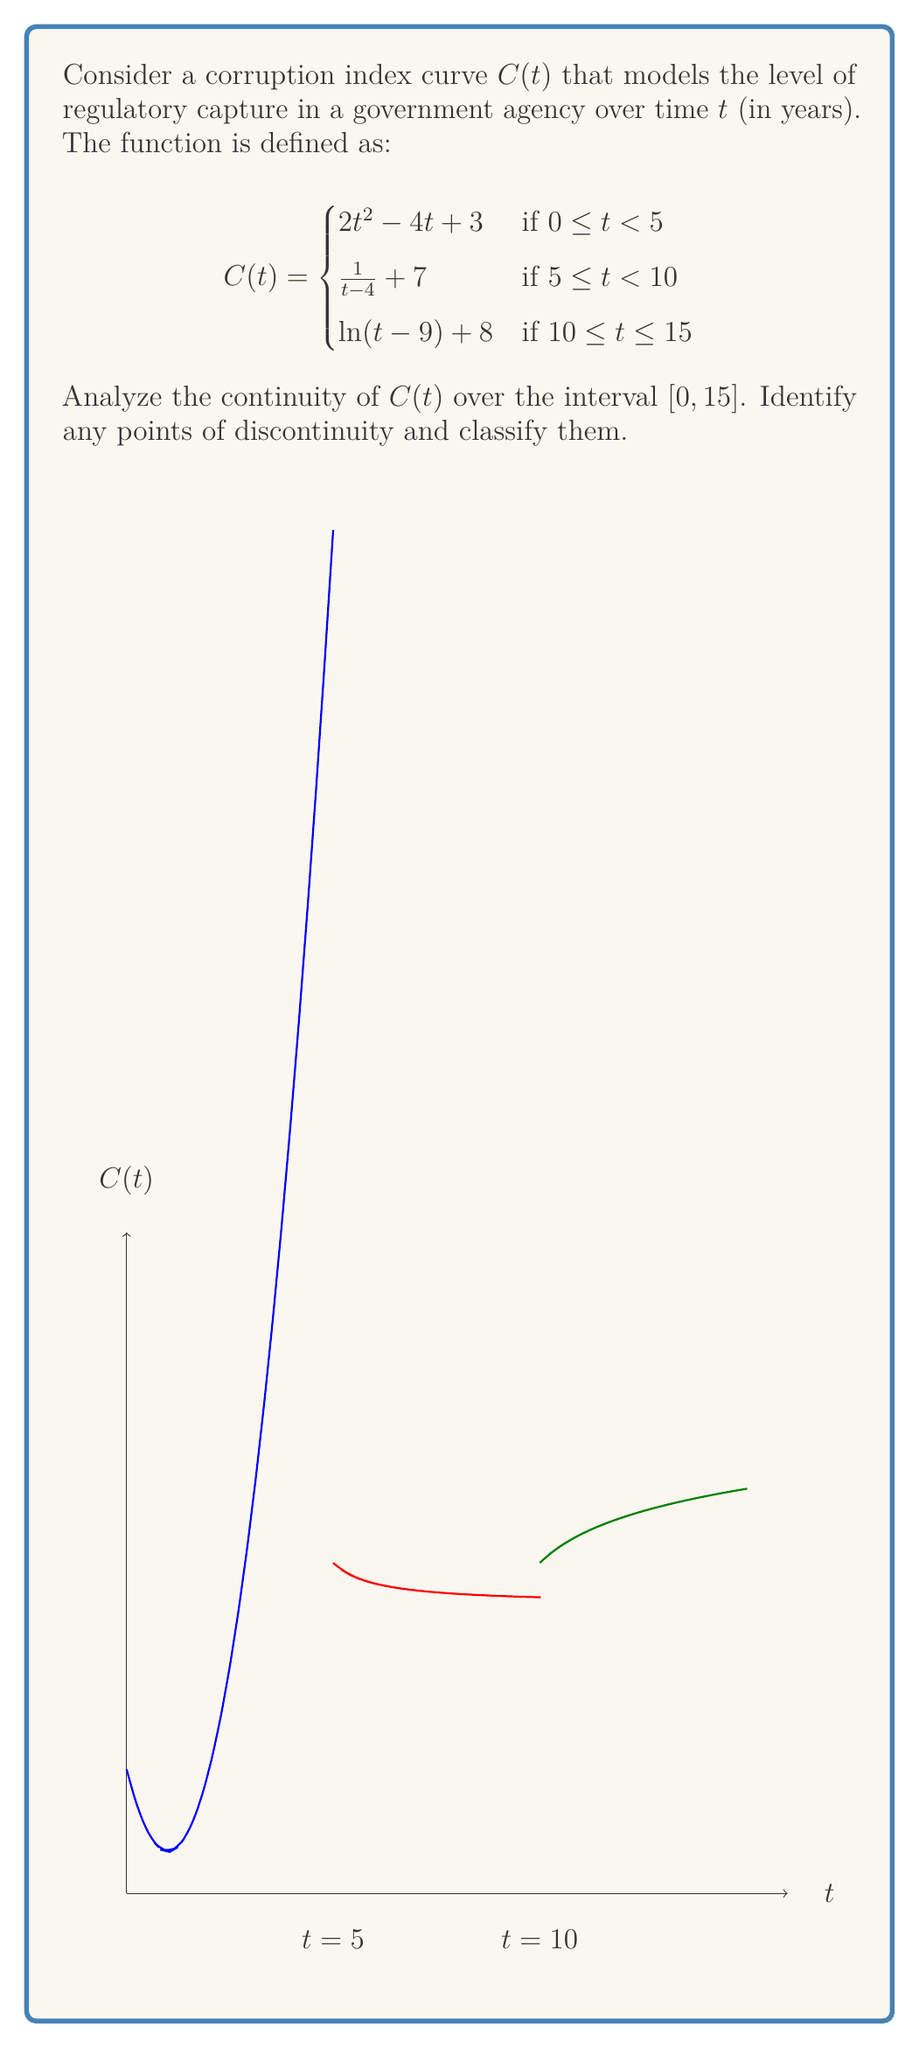Give your solution to this math problem. To analyze the continuity of $C(t)$ over $[0, 15]$, we need to check:
1. Continuity within each piece
2. Continuity at the transition points $t=5$ and $t=10$

Step 1: Continuity within each piece
- For $0 \leq t < 5$: $2t^2 - 4t + 3$ is a polynomial, thus continuous.
- For $5 \leq t < 10$: $\frac{1}{t-4} + 7$ is continuous except at $t=4$, which is outside this interval.
- For $10 \leq t \leq 15$: $\ln(t-9) + 8$ is continuous for $t > 9$, which is satisfied in this interval.

Step 2: Continuity at $t=5$
Left limit: $\lim_{t \to 5^-} (2t^2 - 4t + 3) = 2(5)^2 - 4(5) + 3 = 28$
Right limit: $\lim_{t \to 5^+} (\frac{1}{t-4} + 7) = \frac{1}{5-4} + 7 = 8$
Since the left limit ≠ right limit, $C(t)$ is discontinuous at $t=5$.
This is a jump discontinuity.

Step 3: Continuity at $t=10$
Left limit: $\lim_{t \to 10^-} (\frac{1}{t-4} + 7) = \frac{1}{10-4} + 7 = 7.1667$
Right limit: $\lim_{t \to 10^+} (\ln(t-9) + 8) = \ln(10-9) + 8 = 8$
$C(10) = \ln(10-9) + 8 = 8$
The right limit equals $C(10)$, but the left limit doesn't. This is a jump discontinuity.

Therefore, $C(t)$ has jump discontinuities at $t=5$ and $t=10$, and is continuous elsewhere on $[0, 15]$.
Answer: $C(t)$ is discontinuous at $t=5$ and $t=10$ (jump discontinuities), continuous elsewhere on $[0, 15]$. 